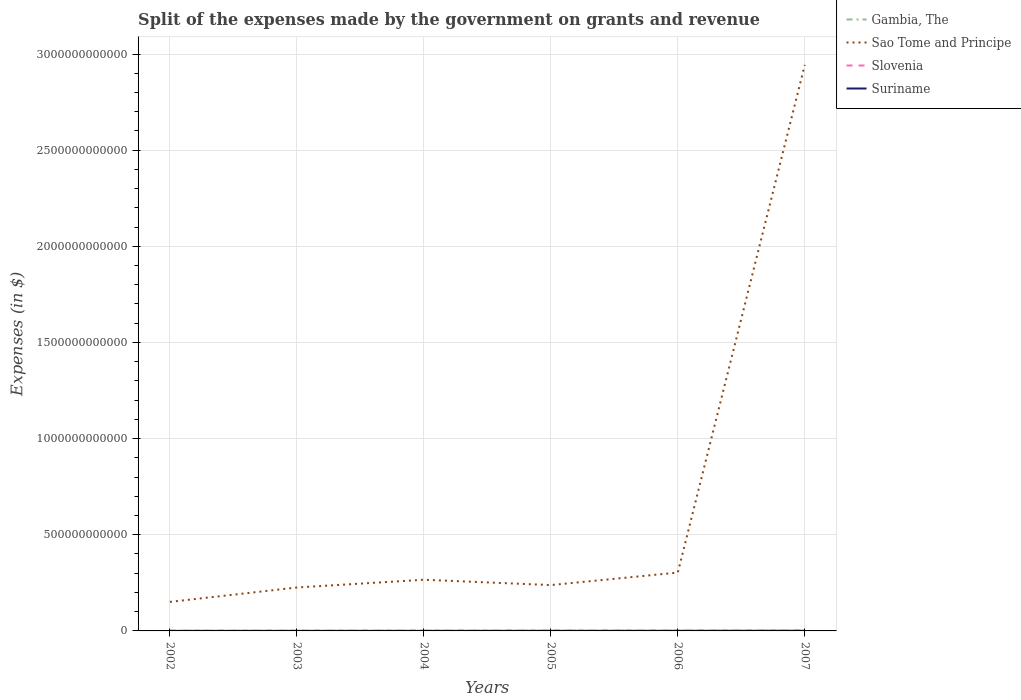How many different coloured lines are there?
Make the answer very short. 4. Does the line corresponding to Sao Tome and Principe intersect with the line corresponding to Suriname?
Your answer should be compact. No. Across all years, what is the maximum expenses made by the government on grants and revenue in Gambia, The?
Offer a terse response. 3.77e+08. In which year was the expenses made by the government on grants and revenue in Gambia, The maximum?
Offer a very short reply. 2006. What is the total expenses made by the government on grants and revenue in Suriname in the graph?
Provide a short and direct response. -4.48e+07. What is the difference between the highest and the second highest expenses made by the government on grants and revenue in Suriname?
Provide a short and direct response. 6.83e+08. What is the difference between the highest and the lowest expenses made by the government on grants and revenue in Gambia, The?
Provide a succinct answer. 3. Is the expenses made by the government on grants and revenue in Sao Tome and Principe strictly greater than the expenses made by the government on grants and revenue in Slovenia over the years?
Give a very brief answer. No. How many lines are there?
Keep it short and to the point. 4. What is the difference between two consecutive major ticks on the Y-axis?
Your answer should be very brief. 5.00e+11. Does the graph contain any zero values?
Ensure brevity in your answer.  No. Where does the legend appear in the graph?
Keep it short and to the point. Top right. How many legend labels are there?
Your answer should be very brief. 4. How are the legend labels stacked?
Make the answer very short. Vertical. What is the title of the graph?
Provide a short and direct response. Split of the expenses made by the government on grants and revenue. Does "Sierra Leone" appear as one of the legend labels in the graph?
Your response must be concise. No. What is the label or title of the Y-axis?
Keep it short and to the point. Expenses (in $). What is the Expenses (in $) of Gambia, The in 2002?
Provide a succinct answer. 4.76e+08. What is the Expenses (in $) of Sao Tome and Principe in 2002?
Your response must be concise. 1.51e+11. What is the Expenses (in $) of Slovenia in 2002?
Make the answer very short. 8.19e+08. What is the Expenses (in $) in Suriname in 2002?
Give a very brief answer. 1.64e+08. What is the Expenses (in $) in Gambia, The in 2003?
Your response must be concise. 4.63e+08. What is the Expenses (in $) in Sao Tome and Principe in 2003?
Your response must be concise. 2.26e+11. What is the Expenses (in $) in Slovenia in 2003?
Ensure brevity in your answer.  8.59e+08. What is the Expenses (in $) of Suriname in 2003?
Your answer should be very brief. 2.09e+08. What is the Expenses (in $) of Gambia, The in 2004?
Your answer should be very brief. 8.10e+08. What is the Expenses (in $) in Sao Tome and Principe in 2004?
Provide a short and direct response. 2.66e+11. What is the Expenses (in $) of Slovenia in 2004?
Ensure brevity in your answer.  1.04e+09. What is the Expenses (in $) in Suriname in 2004?
Give a very brief answer. 2.53e+08. What is the Expenses (in $) of Gambia, The in 2005?
Give a very brief answer. 6.99e+08. What is the Expenses (in $) in Sao Tome and Principe in 2005?
Offer a terse response. 2.38e+11. What is the Expenses (in $) in Slovenia in 2005?
Keep it short and to the point. 1.15e+09. What is the Expenses (in $) of Suriname in 2005?
Your answer should be very brief. 3.94e+08. What is the Expenses (in $) in Gambia, The in 2006?
Ensure brevity in your answer.  3.77e+08. What is the Expenses (in $) of Sao Tome and Principe in 2006?
Offer a terse response. 3.04e+11. What is the Expenses (in $) in Slovenia in 2006?
Your answer should be very brief. 1.16e+09. What is the Expenses (in $) of Suriname in 2006?
Provide a succinct answer. 5.33e+08. What is the Expenses (in $) in Gambia, The in 2007?
Your response must be concise. 5.73e+08. What is the Expenses (in $) in Sao Tome and Principe in 2007?
Your response must be concise. 2.94e+12. What is the Expenses (in $) in Slovenia in 2007?
Give a very brief answer. 1.28e+09. What is the Expenses (in $) of Suriname in 2007?
Keep it short and to the point. 8.47e+08. Across all years, what is the maximum Expenses (in $) in Gambia, The?
Provide a succinct answer. 8.10e+08. Across all years, what is the maximum Expenses (in $) of Sao Tome and Principe?
Offer a very short reply. 2.94e+12. Across all years, what is the maximum Expenses (in $) of Slovenia?
Your response must be concise. 1.28e+09. Across all years, what is the maximum Expenses (in $) of Suriname?
Offer a very short reply. 8.47e+08. Across all years, what is the minimum Expenses (in $) in Gambia, The?
Make the answer very short. 3.77e+08. Across all years, what is the minimum Expenses (in $) in Sao Tome and Principe?
Your answer should be compact. 1.51e+11. Across all years, what is the minimum Expenses (in $) of Slovenia?
Your response must be concise. 8.19e+08. Across all years, what is the minimum Expenses (in $) in Suriname?
Your response must be concise. 1.64e+08. What is the total Expenses (in $) of Gambia, The in the graph?
Give a very brief answer. 3.40e+09. What is the total Expenses (in $) in Sao Tome and Principe in the graph?
Give a very brief answer. 4.13e+12. What is the total Expenses (in $) in Slovenia in the graph?
Provide a succinct answer. 6.30e+09. What is the total Expenses (in $) in Suriname in the graph?
Keep it short and to the point. 2.40e+09. What is the difference between the Expenses (in $) in Gambia, The in 2002 and that in 2003?
Offer a terse response. 1.25e+07. What is the difference between the Expenses (in $) in Sao Tome and Principe in 2002 and that in 2003?
Provide a short and direct response. -7.49e+1. What is the difference between the Expenses (in $) in Slovenia in 2002 and that in 2003?
Offer a terse response. -3.99e+07. What is the difference between the Expenses (in $) of Suriname in 2002 and that in 2003?
Your answer should be compact. -4.48e+07. What is the difference between the Expenses (in $) in Gambia, The in 2002 and that in 2004?
Keep it short and to the point. -3.34e+08. What is the difference between the Expenses (in $) in Sao Tome and Principe in 2002 and that in 2004?
Your answer should be very brief. -1.15e+11. What is the difference between the Expenses (in $) of Slovenia in 2002 and that in 2004?
Your answer should be very brief. -2.19e+08. What is the difference between the Expenses (in $) of Suriname in 2002 and that in 2004?
Offer a terse response. -8.93e+07. What is the difference between the Expenses (in $) of Gambia, The in 2002 and that in 2005?
Provide a succinct answer. -2.24e+08. What is the difference between the Expenses (in $) of Sao Tome and Principe in 2002 and that in 2005?
Make the answer very short. -8.74e+1. What is the difference between the Expenses (in $) of Slovenia in 2002 and that in 2005?
Ensure brevity in your answer.  -3.29e+08. What is the difference between the Expenses (in $) in Suriname in 2002 and that in 2005?
Make the answer very short. -2.30e+08. What is the difference between the Expenses (in $) of Gambia, The in 2002 and that in 2006?
Keep it short and to the point. 9.86e+07. What is the difference between the Expenses (in $) in Sao Tome and Principe in 2002 and that in 2006?
Provide a succinct answer. -1.53e+11. What is the difference between the Expenses (in $) of Slovenia in 2002 and that in 2006?
Make the answer very short. -3.39e+08. What is the difference between the Expenses (in $) of Suriname in 2002 and that in 2006?
Your response must be concise. -3.69e+08. What is the difference between the Expenses (in $) in Gambia, The in 2002 and that in 2007?
Your response must be concise. -9.71e+07. What is the difference between the Expenses (in $) in Sao Tome and Principe in 2002 and that in 2007?
Your response must be concise. -2.79e+12. What is the difference between the Expenses (in $) of Slovenia in 2002 and that in 2007?
Your answer should be very brief. -4.64e+08. What is the difference between the Expenses (in $) of Suriname in 2002 and that in 2007?
Ensure brevity in your answer.  -6.83e+08. What is the difference between the Expenses (in $) of Gambia, The in 2003 and that in 2004?
Give a very brief answer. -3.46e+08. What is the difference between the Expenses (in $) in Sao Tome and Principe in 2003 and that in 2004?
Keep it short and to the point. -4.03e+1. What is the difference between the Expenses (in $) of Slovenia in 2003 and that in 2004?
Give a very brief answer. -1.79e+08. What is the difference between the Expenses (in $) in Suriname in 2003 and that in 2004?
Ensure brevity in your answer.  -4.45e+07. What is the difference between the Expenses (in $) in Gambia, The in 2003 and that in 2005?
Offer a very short reply. -2.36e+08. What is the difference between the Expenses (in $) in Sao Tome and Principe in 2003 and that in 2005?
Make the answer very short. -1.25e+1. What is the difference between the Expenses (in $) in Slovenia in 2003 and that in 2005?
Provide a succinct answer. -2.90e+08. What is the difference between the Expenses (in $) in Suriname in 2003 and that in 2005?
Provide a succinct answer. -1.86e+08. What is the difference between the Expenses (in $) of Gambia, The in 2003 and that in 2006?
Your response must be concise. 8.61e+07. What is the difference between the Expenses (in $) in Sao Tome and Principe in 2003 and that in 2006?
Your answer should be compact. -7.77e+1. What is the difference between the Expenses (in $) in Slovenia in 2003 and that in 2006?
Provide a short and direct response. -2.99e+08. What is the difference between the Expenses (in $) of Suriname in 2003 and that in 2006?
Offer a terse response. -3.24e+08. What is the difference between the Expenses (in $) of Gambia, The in 2003 and that in 2007?
Offer a very short reply. -1.10e+08. What is the difference between the Expenses (in $) in Sao Tome and Principe in 2003 and that in 2007?
Offer a very short reply. -2.72e+12. What is the difference between the Expenses (in $) in Slovenia in 2003 and that in 2007?
Your answer should be very brief. -4.24e+08. What is the difference between the Expenses (in $) in Suriname in 2003 and that in 2007?
Ensure brevity in your answer.  -6.38e+08. What is the difference between the Expenses (in $) in Gambia, The in 2004 and that in 2005?
Offer a terse response. 1.10e+08. What is the difference between the Expenses (in $) in Sao Tome and Principe in 2004 and that in 2005?
Offer a very short reply. 2.78e+1. What is the difference between the Expenses (in $) of Slovenia in 2004 and that in 2005?
Ensure brevity in your answer.  -1.10e+08. What is the difference between the Expenses (in $) in Suriname in 2004 and that in 2005?
Your answer should be compact. -1.41e+08. What is the difference between the Expenses (in $) in Gambia, The in 2004 and that in 2006?
Ensure brevity in your answer.  4.32e+08. What is the difference between the Expenses (in $) of Sao Tome and Principe in 2004 and that in 2006?
Your answer should be very brief. -3.74e+1. What is the difference between the Expenses (in $) of Slovenia in 2004 and that in 2006?
Provide a short and direct response. -1.20e+08. What is the difference between the Expenses (in $) of Suriname in 2004 and that in 2006?
Your response must be concise. -2.80e+08. What is the difference between the Expenses (in $) in Gambia, The in 2004 and that in 2007?
Offer a very short reply. 2.37e+08. What is the difference between the Expenses (in $) of Sao Tome and Principe in 2004 and that in 2007?
Provide a short and direct response. -2.68e+12. What is the difference between the Expenses (in $) in Slovenia in 2004 and that in 2007?
Keep it short and to the point. -2.45e+08. What is the difference between the Expenses (in $) of Suriname in 2004 and that in 2007?
Give a very brief answer. -5.94e+08. What is the difference between the Expenses (in $) of Gambia, The in 2005 and that in 2006?
Give a very brief answer. 3.22e+08. What is the difference between the Expenses (in $) in Sao Tome and Principe in 2005 and that in 2006?
Ensure brevity in your answer.  -6.52e+1. What is the difference between the Expenses (in $) of Slovenia in 2005 and that in 2006?
Offer a terse response. -9.36e+06. What is the difference between the Expenses (in $) of Suriname in 2005 and that in 2006?
Ensure brevity in your answer.  -1.39e+08. What is the difference between the Expenses (in $) in Gambia, The in 2005 and that in 2007?
Your answer should be compact. 1.26e+08. What is the difference between the Expenses (in $) of Sao Tome and Principe in 2005 and that in 2007?
Provide a short and direct response. -2.71e+12. What is the difference between the Expenses (in $) in Slovenia in 2005 and that in 2007?
Make the answer very short. -1.35e+08. What is the difference between the Expenses (in $) in Suriname in 2005 and that in 2007?
Your response must be concise. -4.53e+08. What is the difference between the Expenses (in $) of Gambia, The in 2006 and that in 2007?
Offer a very short reply. -1.96e+08. What is the difference between the Expenses (in $) of Sao Tome and Principe in 2006 and that in 2007?
Offer a very short reply. -2.64e+12. What is the difference between the Expenses (in $) in Slovenia in 2006 and that in 2007?
Your answer should be very brief. -1.25e+08. What is the difference between the Expenses (in $) of Suriname in 2006 and that in 2007?
Ensure brevity in your answer.  -3.14e+08. What is the difference between the Expenses (in $) of Gambia, The in 2002 and the Expenses (in $) of Sao Tome and Principe in 2003?
Offer a terse response. -2.25e+11. What is the difference between the Expenses (in $) of Gambia, The in 2002 and the Expenses (in $) of Slovenia in 2003?
Offer a terse response. -3.83e+08. What is the difference between the Expenses (in $) in Gambia, The in 2002 and the Expenses (in $) in Suriname in 2003?
Keep it short and to the point. 2.67e+08. What is the difference between the Expenses (in $) of Sao Tome and Principe in 2002 and the Expenses (in $) of Slovenia in 2003?
Keep it short and to the point. 1.50e+11. What is the difference between the Expenses (in $) in Sao Tome and Principe in 2002 and the Expenses (in $) in Suriname in 2003?
Keep it short and to the point. 1.51e+11. What is the difference between the Expenses (in $) in Slovenia in 2002 and the Expenses (in $) in Suriname in 2003?
Provide a succinct answer. 6.10e+08. What is the difference between the Expenses (in $) of Gambia, The in 2002 and the Expenses (in $) of Sao Tome and Principe in 2004?
Your answer should be compact. -2.66e+11. What is the difference between the Expenses (in $) of Gambia, The in 2002 and the Expenses (in $) of Slovenia in 2004?
Ensure brevity in your answer.  -5.62e+08. What is the difference between the Expenses (in $) of Gambia, The in 2002 and the Expenses (in $) of Suriname in 2004?
Offer a terse response. 2.23e+08. What is the difference between the Expenses (in $) of Sao Tome and Principe in 2002 and the Expenses (in $) of Slovenia in 2004?
Offer a very short reply. 1.50e+11. What is the difference between the Expenses (in $) in Sao Tome and Principe in 2002 and the Expenses (in $) in Suriname in 2004?
Keep it short and to the point. 1.51e+11. What is the difference between the Expenses (in $) in Slovenia in 2002 and the Expenses (in $) in Suriname in 2004?
Ensure brevity in your answer.  5.65e+08. What is the difference between the Expenses (in $) of Gambia, The in 2002 and the Expenses (in $) of Sao Tome and Principe in 2005?
Offer a very short reply. -2.38e+11. What is the difference between the Expenses (in $) in Gambia, The in 2002 and the Expenses (in $) in Slovenia in 2005?
Offer a terse response. -6.72e+08. What is the difference between the Expenses (in $) of Gambia, The in 2002 and the Expenses (in $) of Suriname in 2005?
Offer a terse response. 8.15e+07. What is the difference between the Expenses (in $) of Sao Tome and Principe in 2002 and the Expenses (in $) of Slovenia in 2005?
Ensure brevity in your answer.  1.50e+11. What is the difference between the Expenses (in $) in Sao Tome and Principe in 2002 and the Expenses (in $) in Suriname in 2005?
Offer a very short reply. 1.51e+11. What is the difference between the Expenses (in $) of Slovenia in 2002 and the Expenses (in $) of Suriname in 2005?
Provide a succinct answer. 4.24e+08. What is the difference between the Expenses (in $) in Gambia, The in 2002 and the Expenses (in $) in Sao Tome and Principe in 2006?
Ensure brevity in your answer.  -3.03e+11. What is the difference between the Expenses (in $) in Gambia, The in 2002 and the Expenses (in $) in Slovenia in 2006?
Provide a succinct answer. -6.82e+08. What is the difference between the Expenses (in $) of Gambia, The in 2002 and the Expenses (in $) of Suriname in 2006?
Make the answer very short. -5.72e+07. What is the difference between the Expenses (in $) in Sao Tome and Principe in 2002 and the Expenses (in $) in Slovenia in 2006?
Your answer should be compact. 1.50e+11. What is the difference between the Expenses (in $) in Sao Tome and Principe in 2002 and the Expenses (in $) in Suriname in 2006?
Provide a short and direct response. 1.50e+11. What is the difference between the Expenses (in $) in Slovenia in 2002 and the Expenses (in $) in Suriname in 2006?
Provide a short and direct response. 2.86e+08. What is the difference between the Expenses (in $) of Gambia, The in 2002 and the Expenses (in $) of Sao Tome and Principe in 2007?
Offer a very short reply. -2.94e+12. What is the difference between the Expenses (in $) of Gambia, The in 2002 and the Expenses (in $) of Slovenia in 2007?
Ensure brevity in your answer.  -8.07e+08. What is the difference between the Expenses (in $) of Gambia, The in 2002 and the Expenses (in $) of Suriname in 2007?
Offer a very short reply. -3.71e+08. What is the difference between the Expenses (in $) in Sao Tome and Principe in 2002 and the Expenses (in $) in Slovenia in 2007?
Your answer should be very brief. 1.50e+11. What is the difference between the Expenses (in $) in Sao Tome and Principe in 2002 and the Expenses (in $) in Suriname in 2007?
Ensure brevity in your answer.  1.50e+11. What is the difference between the Expenses (in $) in Slovenia in 2002 and the Expenses (in $) in Suriname in 2007?
Make the answer very short. -2.86e+07. What is the difference between the Expenses (in $) of Gambia, The in 2003 and the Expenses (in $) of Sao Tome and Principe in 2004?
Provide a short and direct response. -2.66e+11. What is the difference between the Expenses (in $) in Gambia, The in 2003 and the Expenses (in $) in Slovenia in 2004?
Make the answer very short. -5.74e+08. What is the difference between the Expenses (in $) in Gambia, The in 2003 and the Expenses (in $) in Suriname in 2004?
Give a very brief answer. 2.10e+08. What is the difference between the Expenses (in $) in Sao Tome and Principe in 2003 and the Expenses (in $) in Slovenia in 2004?
Provide a succinct answer. 2.25e+11. What is the difference between the Expenses (in $) in Sao Tome and Principe in 2003 and the Expenses (in $) in Suriname in 2004?
Offer a very short reply. 2.26e+11. What is the difference between the Expenses (in $) of Slovenia in 2003 and the Expenses (in $) of Suriname in 2004?
Your response must be concise. 6.05e+08. What is the difference between the Expenses (in $) of Gambia, The in 2003 and the Expenses (in $) of Sao Tome and Principe in 2005?
Offer a terse response. -2.38e+11. What is the difference between the Expenses (in $) of Gambia, The in 2003 and the Expenses (in $) of Slovenia in 2005?
Provide a succinct answer. -6.85e+08. What is the difference between the Expenses (in $) of Gambia, The in 2003 and the Expenses (in $) of Suriname in 2005?
Ensure brevity in your answer.  6.90e+07. What is the difference between the Expenses (in $) of Sao Tome and Principe in 2003 and the Expenses (in $) of Slovenia in 2005?
Keep it short and to the point. 2.25e+11. What is the difference between the Expenses (in $) in Sao Tome and Principe in 2003 and the Expenses (in $) in Suriname in 2005?
Ensure brevity in your answer.  2.25e+11. What is the difference between the Expenses (in $) of Slovenia in 2003 and the Expenses (in $) of Suriname in 2005?
Your response must be concise. 4.64e+08. What is the difference between the Expenses (in $) of Gambia, The in 2003 and the Expenses (in $) of Sao Tome and Principe in 2006?
Offer a terse response. -3.03e+11. What is the difference between the Expenses (in $) of Gambia, The in 2003 and the Expenses (in $) of Slovenia in 2006?
Make the answer very short. -6.94e+08. What is the difference between the Expenses (in $) of Gambia, The in 2003 and the Expenses (in $) of Suriname in 2006?
Provide a short and direct response. -6.97e+07. What is the difference between the Expenses (in $) of Sao Tome and Principe in 2003 and the Expenses (in $) of Slovenia in 2006?
Give a very brief answer. 2.25e+11. What is the difference between the Expenses (in $) of Sao Tome and Principe in 2003 and the Expenses (in $) of Suriname in 2006?
Make the answer very short. 2.25e+11. What is the difference between the Expenses (in $) of Slovenia in 2003 and the Expenses (in $) of Suriname in 2006?
Give a very brief answer. 3.25e+08. What is the difference between the Expenses (in $) of Gambia, The in 2003 and the Expenses (in $) of Sao Tome and Principe in 2007?
Keep it short and to the point. -2.94e+12. What is the difference between the Expenses (in $) in Gambia, The in 2003 and the Expenses (in $) in Slovenia in 2007?
Your answer should be compact. -8.19e+08. What is the difference between the Expenses (in $) of Gambia, The in 2003 and the Expenses (in $) of Suriname in 2007?
Give a very brief answer. -3.84e+08. What is the difference between the Expenses (in $) of Sao Tome and Principe in 2003 and the Expenses (in $) of Slovenia in 2007?
Keep it short and to the point. 2.25e+11. What is the difference between the Expenses (in $) in Sao Tome and Principe in 2003 and the Expenses (in $) in Suriname in 2007?
Provide a short and direct response. 2.25e+11. What is the difference between the Expenses (in $) in Slovenia in 2003 and the Expenses (in $) in Suriname in 2007?
Offer a terse response. 1.13e+07. What is the difference between the Expenses (in $) of Gambia, The in 2004 and the Expenses (in $) of Sao Tome and Principe in 2005?
Provide a short and direct response. -2.38e+11. What is the difference between the Expenses (in $) of Gambia, The in 2004 and the Expenses (in $) of Slovenia in 2005?
Offer a very short reply. -3.39e+08. What is the difference between the Expenses (in $) of Gambia, The in 2004 and the Expenses (in $) of Suriname in 2005?
Offer a very short reply. 4.15e+08. What is the difference between the Expenses (in $) in Sao Tome and Principe in 2004 and the Expenses (in $) in Slovenia in 2005?
Provide a short and direct response. 2.65e+11. What is the difference between the Expenses (in $) in Sao Tome and Principe in 2004 and the Expenses (in $) in Suriname in 2005?
Your response must be concise. 2.66e+11. What is the difference between the Expenses (in $) of Slovenia in 2004 and the Expenses (in $) of Suriname in 2005?
Your answer should be very brief. 6.43e+08. What is the difference between the Expenses (in $) in Gambia, The in 2004 and the Expenses (in $) in Sao Tome and Principe in 2006?
Offer a terse response. -3.03e+11. What is the difference between the Expenses (in $) in Gambia, The in 2004 and the Expenses (in $) in Slovenia in 2006?
Give a very brief answer. -3.48e+08. What is the difference between the Expenses (in $) of Gambia, The in 2004 and the Expenses (in $) of Suriname in 2006?
Keep it short and to the point. 2.76e+08. What is the difference between the Expenses (in $) of Sao Tome and Principe in 2004 and the Expenses (in $) of Slovenia in 2006?
Your response must be concise. 2.65e+11. What is the difference between the Expenses (in $) of Sao Tome and Principe in 2004 and the Expenses (in $) of Suriname in 2006?
Offer a terse response. 2.66e+11. What is the difference between the Expenses (in $) in Slovenia in 2004 and the Expenses (in $) in Suriname in 2006?
Ensure brevity in your answer.  5.05e+08. What is the difference between the Expenses (in $) in Gambia, The in 2004 and the Expenses (in $) in Sao Tome and Principe in 2007?
Your response must be concise. -2.94e+12. What is the difference between the Expenses (in $) in Gambia, The in 2004 and the Expenses (in $) in Slovenia in 2007?
Keep it short and to the point. -4.73e+08. What is the difference between the Expenses (in $) in Gambia, The in 2004 and the Expenses (in $) in Suriname in 2007?
Offer a very short reply. -3.77e+07. What is the difference between the Expenses (in $) of Sao Tome and Principe in 2004 and the Expenses (in $) of Slovenia in 2007?
Offer a terse response. 2.65e+11. What is the difference between the Expenses (in $) of Sao Tome and Principe in 2004 and the Expenses (in $) of Suriname in 2007?
Ensure brevity in your answer.  2.65e+11. What is the difference between the Expenses (in $) in Slovenia in 2004 and the Expenses (in $) in Suriname in 2007?
Offer a terse response. 1.91e+08. What is the difference between the Expenses (in $) in Gambia, The in 2005 and the Expenses (in $) in Sao Tome and Principe in 2006?
Make the answer very short. -3.03e+11. What is the difference between the Expenses (in $) of Gambia, The in 2005 and the Expenses (in $) of Slovenia in 2006?
Your answer should be very brief. -4.58e+08. What is the difference between the Expenses (in $) in Gambia, The in 2005 and the Expenses (in $) in Suriname in 2006?
Offer a terse response. 1.66e+08. What is the difference between the Expenses (in $) of Sao Tome and Principe in 2005 and the Expenses (in $) of Slovenia in 2006?
Make the answer very short. 2.37e+11. What is the difference between the Expenses (in $) of Sao Tome and Principe in 2005 and the Expenses (in $) of Suriname in 2006?
Give a very brief answer. 2.38e+11. What is the difference between the Expenses (in $) of Slovenia in 2005 and the Expenses (in $) of Suriname in 2006?
Offer a terse response. 6.15e+08. What is the difference between the Expenses (in $) in Gambia, The in 2005 and the Expenses (in $) in Sao Tome and Principe in 2007?
Your answer should be very brief. -2.94e+12. What is the difference between the Expenses (in $) in Gambia, The in 2005 and the Expenses (in $) in Slovenia in 2007?
Offer a very short reply. -5.83e+08. What is the difference between the Expenses (in $) in Gambia, The in 2005 and the Expenses (in $) in Suriname in 2007?
Ensure brevity in your answer.  -1.48e+08. What is the difference between the Expenses (in $) of Sao Tome and Principe in 2005 and the Expenses (in $) of Slovenia in 2007?
Give a very brief answer. 2.37e+11. What is the difference between the Expenses (in $) in Sao Tome and Principe in 2005 and the Expenses (in $) in Suriname in 2007?
Your response must be concise. 2.38e+11. What is the difference between the Expenses (in $) of Slovenia in 2005 and the Expenses (in $) of Suriname in 2007?
Offer a terse response. 3.01e+08. What is the difference between the Expenses (in $) of Gambia, The in 2006 and the Expenses (in $) of Sao Tome and Principe in 2007?
Provide a short and direct response. -2.94e+12. What is the difference between the Expenses (in $) of Gambia, The in 2006 and the Expenses (in $) of Slovenia in 2007?
Make the answer very short. -9.05e+08. What is the difference between the Expenses (in $) in Gambia, The in 2006 and the Expenses (in $) in Suriname in 2007?
Provide a succinct answer. -4.70e+08. What is the difference between the Expenses (in $) of Sao Tome and Principe in 2006 and the Expenses (in $) of Slovenia in 2007?
Make the answer very short. 3.02e+11. What is the difference between the Expenses (in $) of Sao Tome and Principe in 2006 and the Expenses (in $) of Suriname in 2007?
Keep it short and to the point. 3.03e+11. What is the difference between the Expenses (in $) in Slovenia in 2006 and the Expenses (in $) in Suriname in 2007?
Offer a very short reply. 3.10e+08. What is the average Expenses (in $) of Gambia, The per year?
Your answer should be compact. 5.66e+08. What is the average Expenses (in $) of Sao Tome and Principe per year?
Give a very brief answer. 6.88e+11. What is the average Expenses (in $) of Slovenia per year?
Your answer should be very brief. 1.05e+09. What is the average Expenses (in $) of Suriname per year?
Your answer should be very brief. 4.00e+08. In the year 2002, what is the difference between the Expenses (in $) of Gambia, The and Expenses (in $) of Sao Tome and Principe?
Your answer should be compact. -1.51e+11. In the year 2002, what is the difference between the Expenses (in $) in Gambia, The and Expenses (in $) in Slovenia?
Your response must be concise. -3.43e+08. In the year 2002, what is the difference between the Expenses (in $) in Gambia, The and Expenses (in $) in Suriname?
Provide a short and direct response. 3.12e+08. In the year 2002, what is the difference between the Expenses (in $) in Sao Tome and Principe and Expenses (in $) in Slovenia?
Provide a succinct answer. 1.50e+11. In the year 2002, what is the difference between the Expenses (in $) of Sao Tome and Principe and Expenses (in $) of Suriname?
Give a very brief answer. 1.51e+11. In the year 2002, what is the difference between the Expenses (in $) in Slovenia and Expenses (in $) in Suriname?
Your answer should be compact. 6.55e+08. In the year 2003, what is the difference between the Expenses (in $) in Gambia, The and Expenses (in $) in Sao Tome and Principe?
Provide a short and direct response. -2.25e+11. In the year 2003, what is the difference between the Expenses (in $) of Gambia, The and Expenses (in $) of Slovenia?
Ensure brevity in your answer.  -3.95e+08. In the year 2003, what is the difference between the Expenses (in $) in Gambia, The and Expenses (in $) in Suriname?
Your answer should be very brief. 2.55e+08. In the year 2003, what is the difference between the Expenses (in $) of Sao Tome and Principe and Expenses (in $) of Slovenia?
Keep it short and to the point. 2.25e+11. In the year 2003, what is the difference between the Expenses (in $) of Sao Tome and Principe and Expenses (in $) of Suriname?
Offer a terse response. 2.26e+11. In the year 2003, what is the difference between the Expenses (in $) of Slovenia and Expenses (in $) of Suriname?
Offer a very short reply. 6.50e+08. In the year 2004, what is the difference between the Expenses (in $) of Gambia, The and Expenses (in $) of Sao Tome and Principe?
Give a very brief answer. -2.65e+11. In the year 2004, what is the difference between the Expenses (in $) of Gambia, The and Expenses (in $) of Slovenia?
Make the answer very short. -2.28e+08. In the year 2004, what is the difference between the Expenses (in $) in Gambia, The and Expenses (in $) in Suriname?
Offer a terse response. 5.56e+08. In the year 2004, what is the difference between the Expenses (in $) of Sao Tome and Principe and Expenses (in $) of Slovenia?
Ensure brevity in your answer.  2.65e+11. In the year 2004, what is the difference between the Expenses (in $) in Sao Tome and Principe and Expenses (in $) in Suriname?
Give a very brief answer. 2.66e+11. In the year 2004, what is the difference between the Expenses (in $) in Slovenia and Expenses (in $) in Suriname?
Provide a short and direct response. 7.84e+08. In the year 2005, what is the difference between the Expenses (in $) of Gambia, The and Expenses (in $) of Sao Tome and Principe?
Keep it short and to the point. -2.38e+11. In the year 2005, what is the difference between the Expenses (in $) in Gambia, The and Expenses (in $) in Slovenia?
Make the answer very short. -4.49e+08. In the year 2005, what is the difference between the Expenses (in $) of Gambia, The and Expenses (in $) of Suriname?
Your response must be concise. 3.05e+08. In the year 2005, what is the difference between the Expenses (in $) of Sao Tome and Principe and Expenses (in $) of Slovenia?
Your answer should be very brief. 2.37e+11. In the year 2005, what is the difference between the Expenses (in $) of Sao Tome and Principe and Expenses (in $) of Suriname?
Your answer should be compact. 2.38e+11. In the year 2005, what is the difference between the Expenses (in $) in Slovenia and Expenses (in $) in Suriname?
Provide a succinct answer. 7.54e+08. In the year 2006, what is the difference between the Expenses (in $) in Gambia, The and Expenses (in $) in Sao Tome and Principe?
Ensure brevity in your answer.  -3.03e+11. In the year 2006, what is the difference between the Expenses (in $) of Gambia, The and Expenses (in $) of Slovenia?
Offer a very short reply. -7.80e+08. In the year 2006, what is the difference between the Expenses (in $) in Gambia, The and Expenses (in $) in Suriname?
Ensure brevity in your answer.  -1.56e+08. In the year 2006, what is the difference between the Expenses (in $) of Sao Tome and Principe and Expenses (in $) of Slovenia?
Provide a succinct answer. 3.02e+11. In the year 2006, what is the difference between the Expenses (in $) of Sao Tome and Principe and Expenses (in $) of Suriname?
Your answer should be compact. 3.03e+11. In the year 2006, what is the difference between the Expenses (in $) in Slovenia and Expenses (in $) in Suriname?
Offer a terse response. 6.24e+08. In the year 2007, what is the difference between the Expenses (in $) in Gambia, The and Expenses (in $) in Sao Tome and Principe?
Give a very brief answer. -2.94e+12. In the year 2007, what is the difference between the Expenses (in $) of Gambia, The and Expenses (in $) of Slovenia?
Your answer should be compact. -7.10e+08. In the year 2007, what is the difference between the Expenses (in $) of Gambia, The and Expenses (in $) of Suriname?
Ensure brevity in your answer.  -2.74e+08. In the year 2007, what is the difference between the Expenses (in $) of Sao Tome and Principe and Expenses (in $) of Slovenia?
Ensure brevity in your answer.  2.94e+12. In the year 2007, what is the difference between the Expenses (in $) of Sao Tome and Principe and Expenses (in $) of Suriname?
Your response must be concise. 2.94e+12. In the year 2007, what is the difference between the Expenses (in $) in Slovenia and Expenses (in $) in Suriname?
Offer a very short reply. 4.35e+08. What is the ratio of the Expenses (in $) of Gambia, The in 2002 to that in 2003?
Offer a very short reply. 1.03. What is the ratio of the Expenses (in $) in Sao Tome and Principe in 2002 to that in 2003?
Provide a succinct answer. 0.67. What is the ratio of the Expenses (in $) of Slovenia in 2002 to that in 2003?
Provide a succinct answer. 0.95. What is the ratio of the Expenses (in $) of Suriname in 2002 to that in 2003?
Ensure brevity in your answer.  0.79. What is the ratio of the Expenses (in $) of Gambia, The in 2002 to that in 2004?
Ensure brevity in your answer.  0.59. What is the ratio of the Expenses (in $) in Sao Tome and Principe in 2002 to that in 2004?
Your answer should be compact. 0.57. What is the ratio of the Expenses (in $) of Slovenia in 2002 to that in 2004?
Offer a terse response. 0.79. What is the ratio of the Expenses (in $) in Suriname in 2002 to that in 2004?
Offer a terse response. 0.65. What is the ratio of the Expenses (in $) of Gambia, The in 2002 to that in 2005?
Offer a very short reply. 0.68. What is the ratio of the Expenses (in $) of Sao Tome and Principe in 2002 to that in 2005?
Offer a terse response. 0.63. What is the ratio of the Expenses (in $) in Slovenia in 2002 to that in 2005?
Offer a terse response. 0.71. What is the ratio of the Expenses (in $) of Suriname in 2002 to that in 2005?
Keep it short and to the point. 0.42. What is the ratio of the Expenses (in $) of Gambia, The in 2002 to that in 2006?
Keep it short and to the point. 1.26. What is the ratio of the Expenses (in $) of Sao Tome and Principe in 2002 to that in 2006?
Your answer should be compact. 0.5. What is the ratio of the Expenses (in $) of Slovenia in 2002 to that in 2006?
Make the answer very short. 0.71. What is the ratio of the Expenses (in $) in Suriname in 2002 to that in 2006?
Keep it short and to the point. 0.31. What is the ratio of the Expenses (in $) in Gambia, The in 2002 to that in 2007?
Ensure brevity in your answer.  0.83. What is the ratio of the Expenses (in $) in Sao Tome and Principe in 2002 to that in 2007?
Your answer should be very brief. 0.05. What is the ratio of the Expenses (in $) of Slovenia in 2002 to that in 2007?
Your response must be concise. 0.64. What is the ratio of the Expenses (in $) of Suriname in 2002 to that in 2007?
Your answer should be compact. 0.19. What is the ratio of the Expenses (in $) in Gambia, The in 2003 to that in 2004?
Keep it short and to the point. 0.57. What is the ratio of the Expenses (in $) in Sao Tome and Principe in 2003 to that in 2004?
Ensure brevity in your answer.  0.85. What is the ratio of the Expenses (in $) of Slovenia in 2003 to that in 2004?
Provide a succinct answer. 0.83. What is the ratio of the Expenses (in $) in Suriname in 2003 to that in 2004?
Your answer should be very brief. 0.82. What is the ratio of the Expenses (in $) in Gambia, The in 2003 to that in 2005?
Your answer should be very brief. 0.66. What is the ratio of the Expenses (in $) of Sao Tome and Principe in 2003 to that in 2005?
Ensure brevity in your answer.  0.95. What is the ratio of the Expenses (in $) in Slovenia in 2003 to that in 2005?
Your answer should be very brief. 0.75. What is the ratio of the Expenses (in $) in Suriname in 2003 to that in 2005?
Ensure brevity in your answer.  0.53. What is the ratio of the Expenses (in $) of Gambia, The in 2003 to that in 2006?
Provide a short and direct response. 1.23. What is the ratio of the Expenses (in $) in Sao Tome and Principe in 2003 to that in 2006?
Offer a very short reply. 0.74. What is the ratio of the Expenses (in $) of Slovenia in 2003 to that in 2006?
Give a very brief answer. 0.74. What is the ratio of the Expenses (in $) of Suriname in 2003 to that in 2006?
Offer a very short reply. 0.39. What is the ratio of the Expenses (in $) of Gambia, The in 2003 to that in 2007?
Your answer should be compact. 0.81. What is the ratio of the Expenses (in $) in Sao Tome and Principe in 2003 to that in 2007?
Give a very brief answer. 0.08. What is the ratio of the Expenses (in $) of Slovenia in 2003 to that in 2007?
Give a very brief answer. 0.67. What is the ratio of the Expenses (in $) of Suriname in 2003 to that in 2007?
Provide a succinct answer. 0.25. What is the ratio of the Expenses (in $) in Gambia, The in 2004 to that in 2005?
Offer a terse response. 1.16. What is the ratio of the Expenses (in $) of Sao Tome and Principe in 2004 to that in 2005?
Keep it short and to the point. 1.12. What is the ratio of the Expenses (in $) in Slovenia in 2004 to that in 2005?
Provide a succinct answer. 0.9. What is the ratio of the Expenses (in $) in Suriname in 2004 to that in 2005?
Give a very brief answer. 0.64. What is the ratio of the Expenses (in $) in Gambia, The in 2004 to that in 2006?
Offer a very short reply. 2.15. What is the ratio of the Expenses (in $) of Sao Tome and Principe in 2004 to that in 2006?
Make the answer very short. 0.88. What is the ratio of the Expenses (in $) of Slovenia in 2004 to that in 2006?
Provide a short and direct response. 0.9. What is the ratio of the Expenses (in $) in Suriname in 2004 to that in 2006?
Keep it short and to the point. 0.48. What is the ratio of the Expenses (in $) of Gambia, The in 2004 to that in 2007?
Provide a short and direct response. 1.41. What is the ratio of the Expenses (in $) of Sao Tome and Principe in 2004 to that in 2007?
Offer a very short reply. 0.09. What is the ratio of the Expenses (in $) in Slovenia in 2004 to that in 2007?
Make the answer very short. 0.81. What is the ratio of the Expenses (in $) of Suriname in 2004 to that in 2007?
Your response must be concise. 0.3. What is the ratio of the Expenses (in $) of Gambia, The in 2005 to that in 2006?
Give a very brief answer. 1.85. What is the ratio of the Expenses (in $) in Sao Tome and Principe in 2005 to that in 2006?
Keep it short and to the point. 0.79. What is the ratio of the Expenses (in $) of Suriname in 2005 to that in 2006?
Provide a short and direct response. 0.74. What is the ratio of the Expenses (in $) of Gambia, The in 2005 to that in 2007?
Make the answer very short. 1.22. What is the ratio of the Expenses (in $) of Sao Tome and Principe in 2005 to that in 2007?
Your answer should be very brief. 0.08. What is the ratio of the Expenses (in $) in Slovenia in 2005 to that in 2007?
Ensure brevity in your answer.  0.9. What is the ratio of the Expenses (in $) in Suriname in 2005 to that in 2007?
Make the answer very short. 0.47. What is the ratio of the Expenses (in $) in Gambia, The in 2006 to that in 2007?
Give a very brief answer. 0.66. What is the ratio of the Expenses (in $) of Sao Tome and Principe in 2006 to that in 2007?
Your answer should be compact. 0.1. What is the ratio of the Expenses (in $) of Slovenia in 2006 to that in 2007?
Your answer should be compact. 0.9. What is the ratio of the Expenses (in $) in Suriname in 2006 to that in 2007?
Ensure brevity in your answer.  0.63. What is the difference between the highest and the second highest Expenses (in $) in Gambia, The?
Ensure brevity in your answer.  1.10e+08. What is the difference between the highest and the second highest Expenses (in $) in Sao Tome and Principe?
Make the answer very short. 2.64e+12. What is the difference between the highest and the second highest Expenses (in $) in Slovenia?
Give a very brief answer. 1.25e+08. What is the difference between the highest and the second highest Expenses (in $) of Suriname?
Provide a short and direct response. 3.14e+08. What is the difference between the highest and the lowest Expenses (in $) of Gambia, The?
Make the answer very short. 4.32e+08. What is the difference between the highest and the lowest Expenses (in $) of Sao Tome and Principe?
Your answer should be compact. 2.79e+12. What is the difference between the highest and the lowest Expenses (in $) in Slovenia?
Offer a very short reply. 4.64e+08. What is the difference between the highest and the lowest Expenses (in $) in Suriname?
Give a very brief answer. 6.83e+08. 